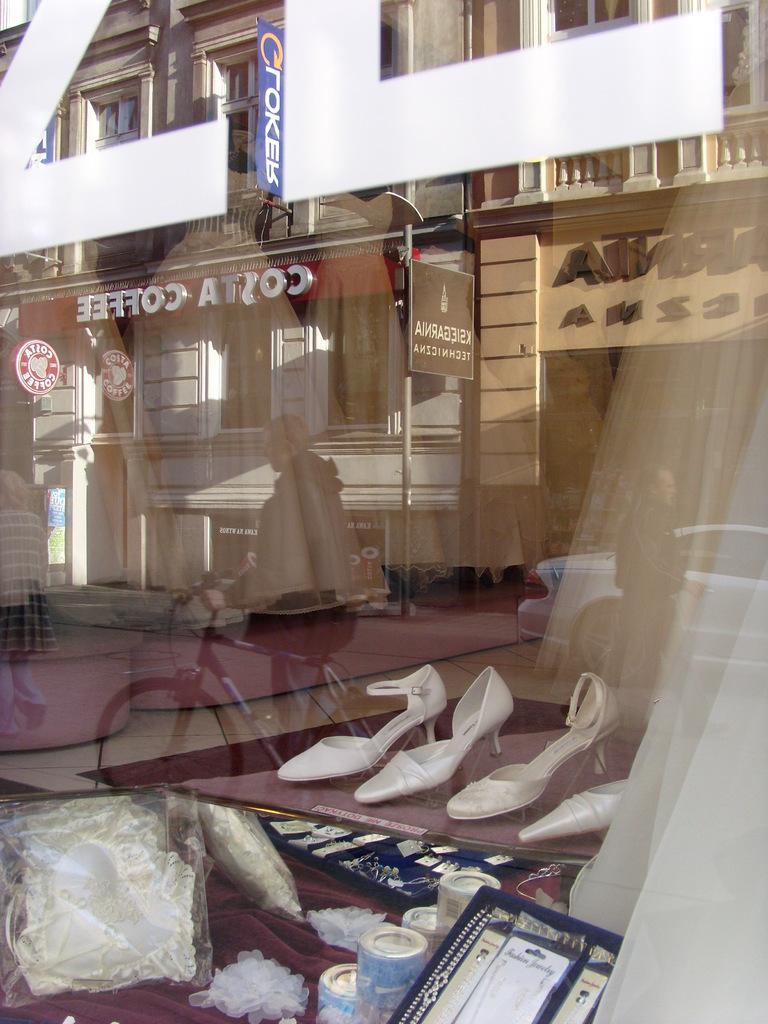Could you give a brief overview of what you see in this image? In this image I can see a glass, through glass I can see sandals and a man holding a bi-cycle and a person visible beside the car and I can see a signboard and I can see a building. 